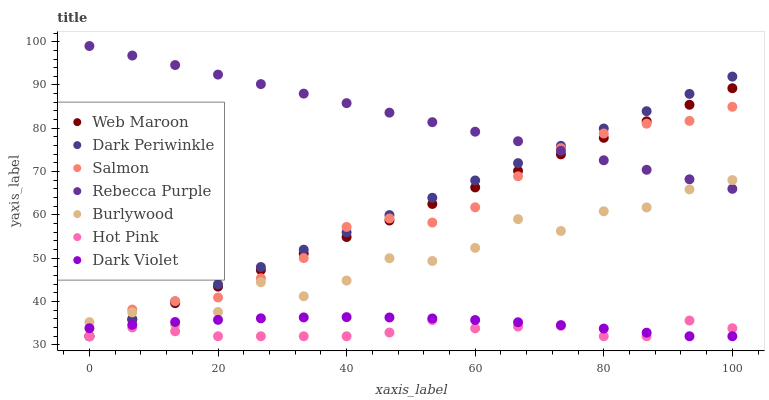Does Hot Pink have the minimum area under the curve?
Answer yes or no. Yes. Does Rebecca Purple have the maximum area under the curve?
Answer yes or no. Yes. Does Web Maroon have the minimum area under the curve?
Answer yes or no. No. Does Web Maroon have the maximum area under the curve?
Answer yes or no. No. Is Web Maroon the smoothest?
Answer yes or no. Yes. Is Burlywood the roughest?
Answer yes or no. Yes. Is Hot Pink the smoothest?
Answer yes or no. No. Is Hot Pink the roughest?
Answer yes or no. No. Does Web Maroon have the lowest value?
Answer yes or no. Yes. Does Rebecca Purple have the lowest value?
Answer yes or no. No. Does Rebecca Purple have the highest value?
Answer yes or no. Yes. Does Web Maroon have the highest value?
Answer yes or no. No. Is Hot Pink less than Rebecca Purple?
Answer yes or no. Yes. Is Burlywood greater than Hot Pink?
Answer yes or no. Yes. Does Web Maroon intersect Hot Pink?
Answer yes or no. Yes. Is Web Maroon less than Hot Pink?
Answer yes or no. No. Is Web Maroon greater than Hot Pink?
Answer yes or no. No. Does Hot Pink intersect Rebecca Purple?
Answer yes or no. No. 